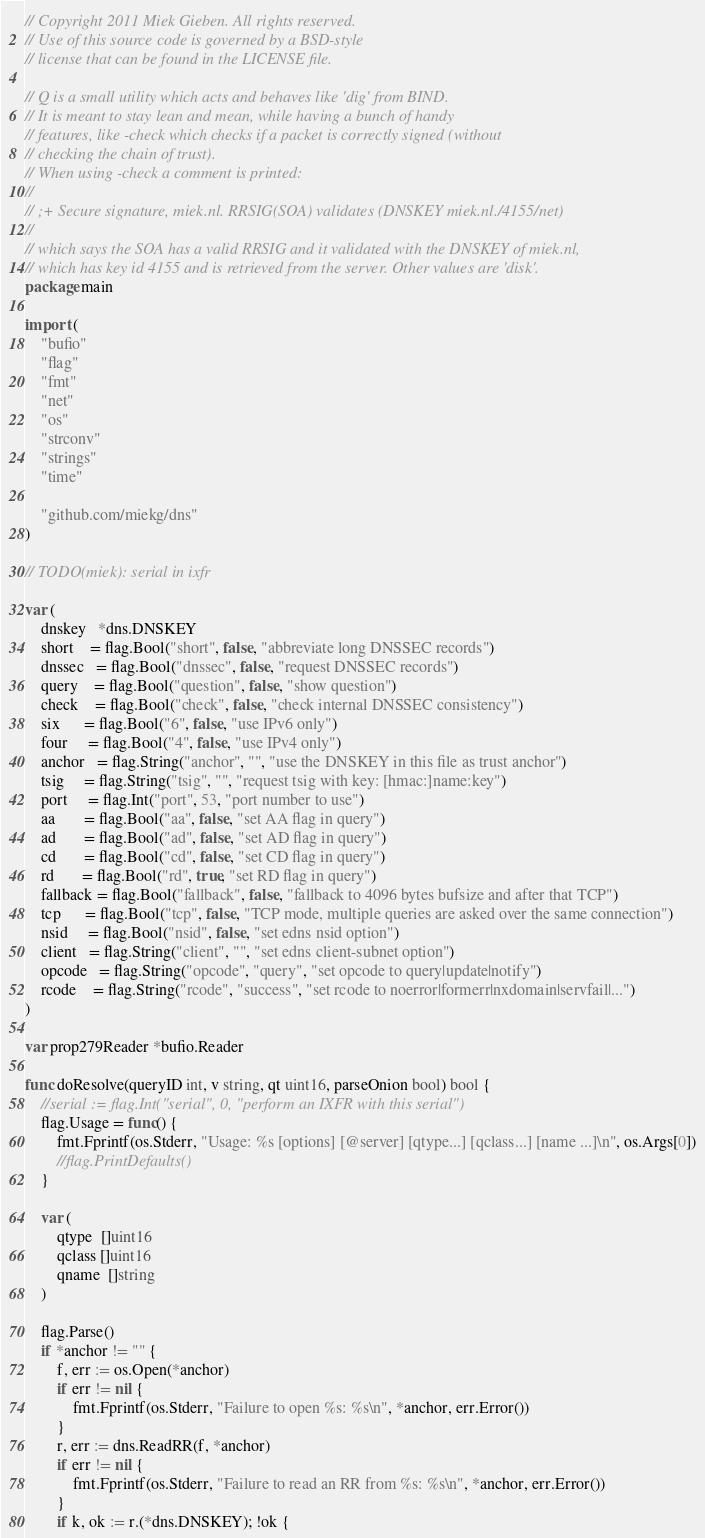Convert code to text. <code><loc_0><loc_0><loc_500><loc_500><_Go_>// Copyright 2011 Miek Gieben. All rights reserved.
// Use of this source code is governed by a BSD-style
// license that can be found in the LICENSE file.

// Q is a small utility which acts and behaves like 'dig' from BIND.
// It is meant to stay lean and mean, while having a bunch of handy
// features, like -check which checks if a packet is correctly signed (without
// checking the chain of trust).
// When using -check a comment is printed:
//
// ;+ Secure signature, miek.nl. RRSIG(SOA) validates (DNSKEY miek.nl./4155/net)
//
// which says the SOA has a valid RRSIG and it validated with the DNSKEY of miek.nl,
// which has key id 4155 and is retrieved from the server. Other values are 'disk'.
package main

import (
	"bufio"
	"flag"
	"fmt"
	"net"
	"os"
	"strconv"
	"strings"
	"time"

	"github.com/miekg/dns"
)

// TODO(miek): serial in ixfr

var (
	dnskey   *dns.DNSKEY
	short    = flag.Bool("short", false, "abbreviate long DNSSEC records")
	dnssec   = flag.Bool("dnssec", false, "request DNSSEC records")
	query    = flag.Bool("question", false, "show question")
	check    = flag.Bool("check", false, "check internal DNSSEC consistency")
	six      = flag.Bool("6", false, "use IPv6 only")
	four     = flag.Bool("4", false, "use IPv4 only")
	anchor   = flag.String("anchor", "", "use the DNSKEY in this file as trust anchor")
	tsig     = flag.String("tsig", "", "request tsig with key: [hmac:]name:key")
	port     = flag.Int("port", 53, "port number to use")
	aa       = flag.Bool("aa", false, "set AA flag in query")
	ad       = flag.Bool("ad", false, "set AD flag in query")
	cd       = flag.Bool("cd", false, "set CD flag in query")
	rd       = flag.Bool("rd", true, "set RD flag in query")
	fallback = flag.Bool("fallback", false, "fallback to 4096 bytes bufsize and after that TCP")
	tcp      = flag.Bool("tcp", false, "TCP mode, multiple queries are asked over the same connection")
	nsid     = flag.Bool("nsid", false, "set edns nsid option")
	client   = flag.String("client", "", "set edns client-subnet option")
	opcode   = flag.String("opcode", "query", "set opcode to query|update|notify")
	rcode    = flag.String("rcode", "success", "set rcode to noerror|formerr|nxdomain|servfail|...")
)

var prop279Reader *bufio.Reader

func doResolve(queryID int, v string, qt uint16, parseOnion bool) bool {
	//serial := flag.Int("serial", 0, "perform an IXFR with this serial")
	flag.Usage = func() {
		fmt.Fprintf(os.Stderr, "Usage: %s [options] [@server] [qtype...] [qclass...] [name ...]\n", os.Args[0])
		//flag.PrintDefaults()
	}

	var (
		qtype  []uint16
		qclass []uint16
		qname  []string
	)

	flag.Parse()
	if *anchor != "" {
		f, err := os.Open(*anchor)
		if err != nil {
			fmt.Fprintf(os.Stderr, "Failure to open %s: %s\n", *anchor, err.Error())
		}
		r, err := dns.ReadRR(f, *anchor)
		if err != nil {
			fmt.Fprintf(os.Stderr, "Failure to read an RR from %s: %s\n", *anchor, err.Error())
		}
		if k, ok := r.(*dns.DNSKEY); !ok {</code> 